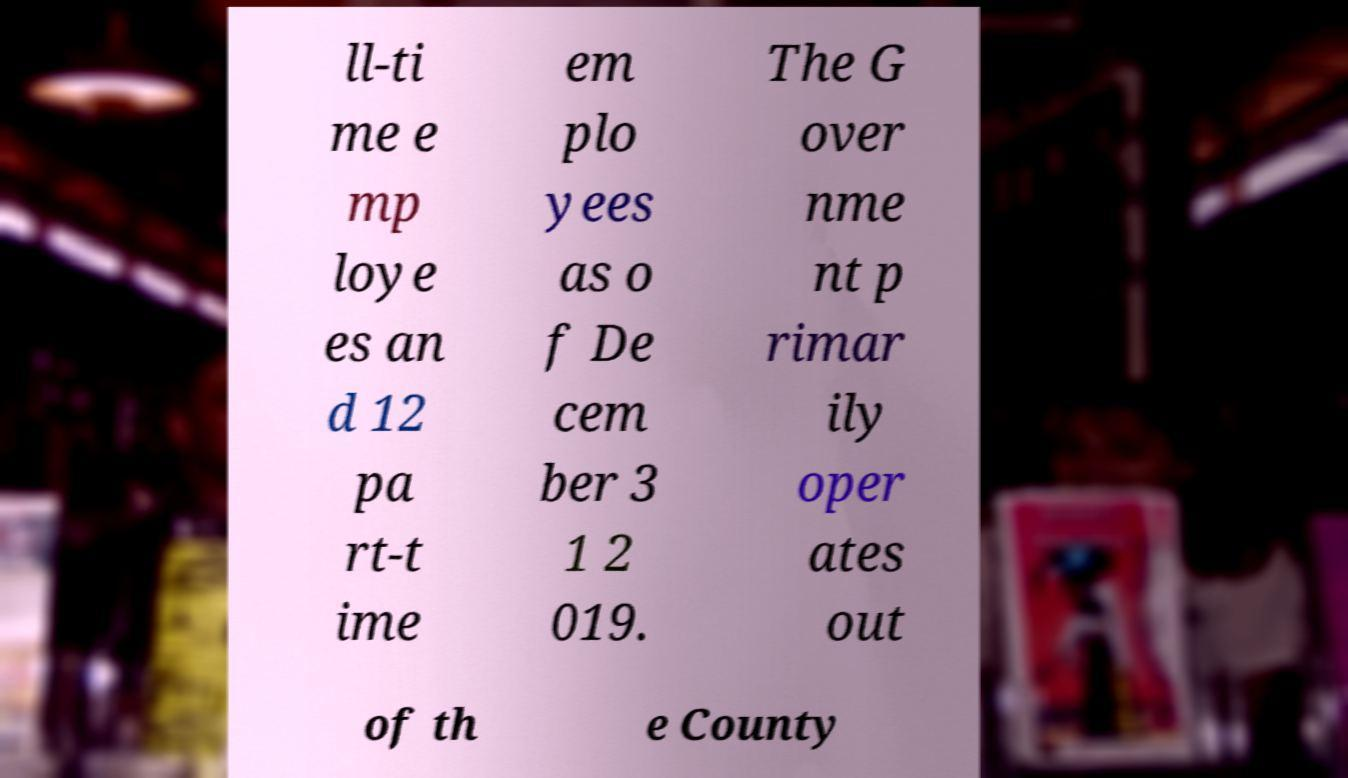Please read and relay the text visible in this image. What does it say? ll-ti me e mp loye es an d 12 pa rt-t ime em plo yees as o f De cem ber 3 1 2 019. The G over nme nt p rimar ily oper ates out of th e County 